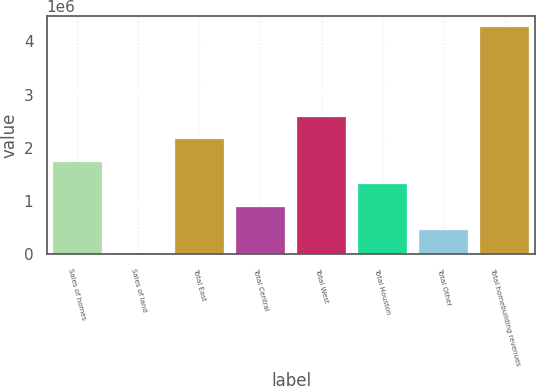Convert chart to OTSL. <chart><loc_0><loc_0><loc_500><loc_500><bar_chart><fcel>Sales of homes<fcel>Sales of land<fcel>Total East<fcel>Total Central<fcel>Total West<fcel>Total Houston<fcel>Total Other<fcel>Total homebuilding revenues<nl><fcel>1.73516e+06<fcel>23033<fcel>2.15916e+06<fcel>887154<fcel>2.58316e+06<fcel>1.31116e+06<fcel>463154<fcel>4.26304e+06<nl></chart> 